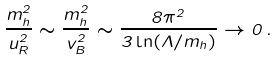Convert formula to latex. <formula><loc_0><loc_0><loc_500><loc_500>\frac { m ^ { 2 } _ { h } } { u ^ { 2 } _ { R } } \sim \frac { m ^ { 2 } _ { h } } { v ^ { 2 } _ { B } } \sim \frac { 8 \pi ^ { 2 } } { 3 \ln ( \Lambda / m _ { h } ) } \to 0 \, .</formula> 